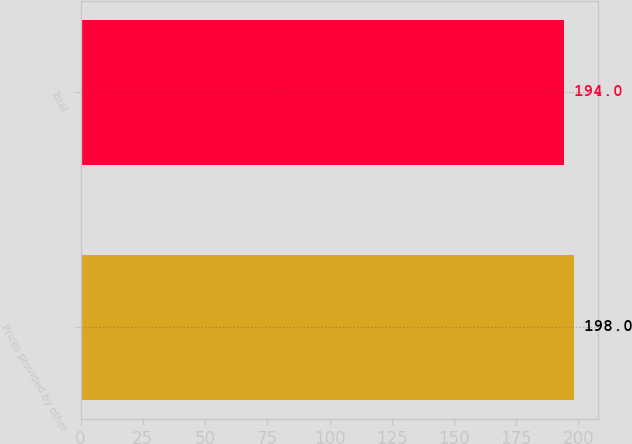<chart> <loc_0><loc_0><loc_500><loc_500><bar_chart><fcel>Prices provided by other<fcel>Total<nl><fcel>198<fcel>194<nl></chart> 